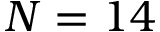<formula> <loc_0><loc_0><loc_500><loc_500>N = 1 4</formula> 